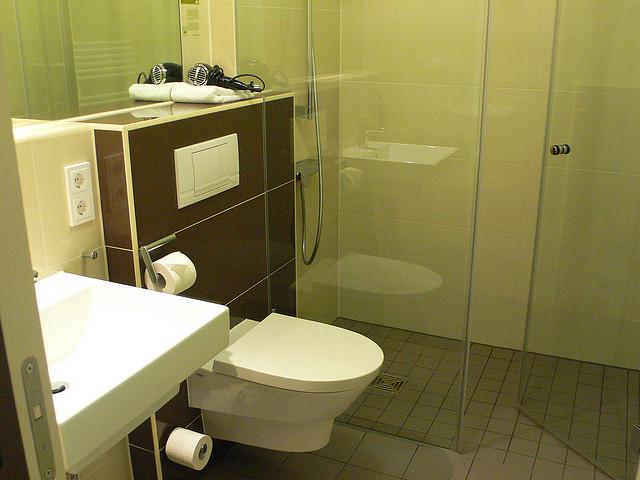Are the shower doors transparent?
Quick response, please. Yes. Is there a standard or international outlet installed?
Write a very short answer. International. Is there a hair dryer on top of the cabinet?
Keep it brief. Yes. What color is the floor?
Keep it brief. Gray. 